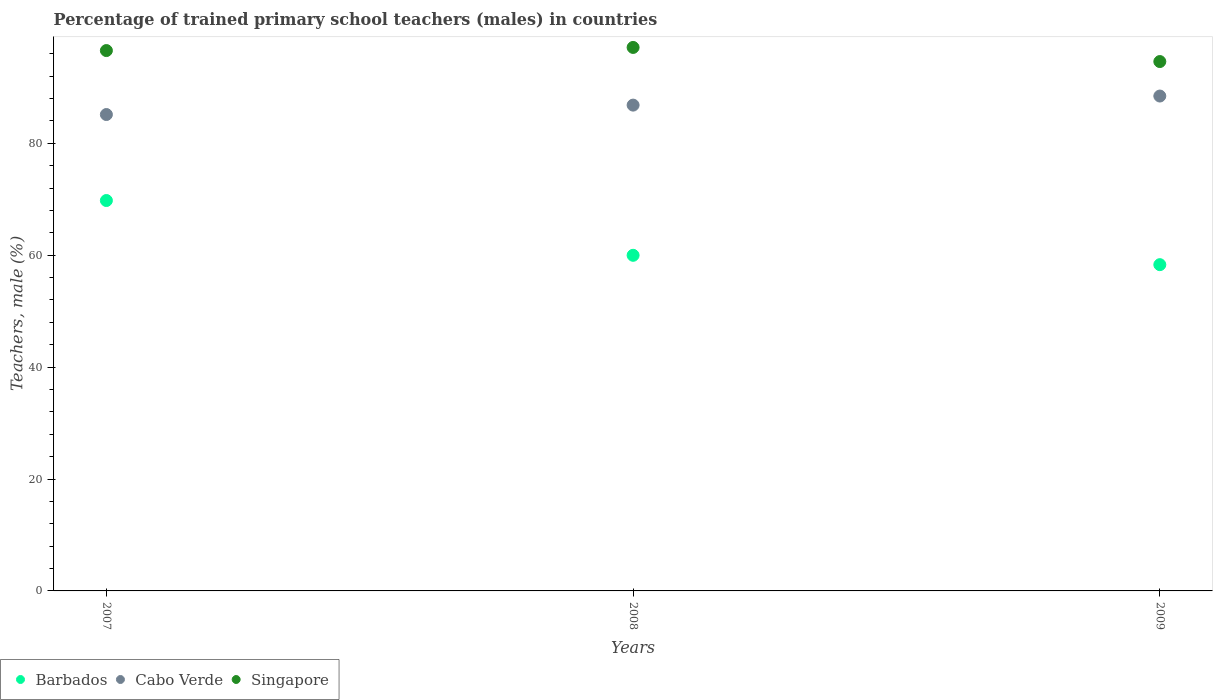What is the percentage of trained primary school teachers (males) in Singapore in 2008?
Your answer should be very brief. 97.14. Across all years, what is the maximum percentage of trained primary school teachers (males) in Cabo Verde?
Offer a very short reply. 88.45. Across all years, what is the minimum percentage of trained primary school teachers (males) in Barbados?
Your response must be concise. 58.31. In which year was the percentage of trained primary school teachers (males) in Singapore maximum?
Offer a very short reply. 2008. What is the total percentage of trained primary school teachers (males) in Cabo Verde in the graph?
Offer a terse response. 260.43. What is the difference between the percentage of trained primary school teachers (males) in Cabo Verde in 2007 and that in 2008?
Your answer should be compact. -1.68. What is the difference between the percentage of trained primary school teachers (males) in Cabo Verde in 2008 and the percentage of trained primary school teachers (males) in Barbados in 2007?
Your answer should be very brief. 17.05. What is the average percentage of trained primary school teachers (males) in Cabo Verde per year?
Your answer should be very brief. 86.81. In the year 2008, what is the difference between the percentage of trained primary school teachers (males) in Cabo Verde and percentage of trained primary school teachers (males) in Singapore?
Your answer should be very brief. -10.31. What is the ratio of the percentage of trained primary school teachers (males) in Singapore in 2008 to that in 2009?
Provide a short and direct response. 1.03. Is the difference between the percentage of trained primary school teachers (males) in Cabo Verde in 2007 and 2009 greater than the difference between the percentage of trained primary school teachers (males) in Singapore in 2007 and 2009?
Your response must be concise. No. What is the difference between the highest and the second highest percentage of trained primary school teachers (males) in Barbados?
Offer a terse response. 9.79. What is the difference between the highest and the lowest percentage of trained primary school teachers (males) in Cabo Verde?
Your answer should be compact. 3.31. In how many years, is the percentage of trained primary school teachers (males) in Cabo Verde greater than the average percentage of trained primary school teachers (males) in Cabo Verde taken over all years?
Your response must be concise. 2. Is it the case that in every year, the sum of the percentage of trained primary school teachers (males) in Barbados and percentage of trained primary school teachers (males) in Singapore  is greater than the percentage of trained primary school teachers (males) in Cabo Verde?
Your answer should be very brief. Yes. Are the values on the major ticks of Y-axis written in scientific E-notation?
Give a very brief answer. No. Does the graph contain grids?
Make the answer very short. No. Where does the legend appear in the graph?
Your answer should be very brief. Bottom left. How are the legend labels stacked?
Offer a very short reply. Horizontal. What is the title of the graph?
Provide a short and direct response. Percentage of trained primary school teachers (males) in countries. Does "Benin" appear as one of the legend labels in the graph?
Offer a very short reply. No. What is the label or title of the X-axis?
Make the answer very short. Years. What is the label or title of the Y-axis?
Give a very brief answer. Teachers, male (%). What is the Teachers, male (%) of Barbados in 2007?
Keep it short and to the point. 69.78. What is the Teachers, male (%) in Cabo Verde in 2007?
Your response must be concise. 85.15. What is the Teachers, male (%) of Singapore in 2007?
Your answer should be compact. 96.58. What is the Teachers, male (%) in Barbados in 2008?
Offer a very short reply. 59.99. What is the Teachers, male (%) of Cabo Verde in 2008?
Ensure brevity in your answer.  86.83. What is the Teachers, male (%) in Singapore in 2008?
Make the answer very short. 97.14. What is the Teachers, male (%) in Barbados in 2009?
Ensure brevity in your answer.  58.31. What is the Teachers, male (%) of Cabo Verde in 2009?
Your answer should be compact. 88.45. What is the Teachers, male (%) in Singapore in 2009?
Ensure brevity in your answer.  94.61. Across all years, what is the maximum Teachers, male (%) in Barbados?
Your answer should be very brief. 69.78. Across all years, what is the maximum Teachers, male (%) in Cabo Verde?
Offer a terse response. 88.45. Across all years, what is the maximum Teachers, male (%) of Singapore?
Your answer should be compact. 97.14. Across all years, what is the minimum Teachers, male (%) in Barbados?
Keep it short and to the point. 58.31. Across all years, what is the minimum Teachers, male (%) of Cabo Verde?
Offer a terse response. 85.15. Across all years, what is the minimum Teachers, male (%) in Singapore?
Your answer should be very brief. 94.61. What is the total Teachers, male (%) of Barbados in the graph?
Provide a short and direct response. 188.08. What is the total Teachers, male (%) in Cabo Verde in the graph?
Your response must be concise. 260.43. What is the total Teachers, male (%) in Singapore in the graph?
Provide a succinct answer. 288.33. What is the difference between the Teachers, male (%) of Barbados in 2007 and that in 2008?
Give a very brief answer. 9.79. What is the difference between the Teachers, male (%) of Cabo Verde in 2007 and that in 2008?
Your response must be concise. -1.68. What is the difference between the Teachers, male (%) of Singapore in 2007 and that in 2008?
Offer a very short reply. -0.56. What is the difference between the Teachers, male (%) of Barbados in 2007 and that in 2009?
Provide a short and direct response. 11.46. What is the difference between the Teachers, male (%) in Cabo Verde in 2007 and that in 2009?
Keep it short and to the point. -3.31. What is the difference between the Teachers, male (%) in Singapore in 2007 and that in 2009?
Make the answer very short. 1.96. What is the difference between the Teachers, male (%) in Barbados in 2008 and that in 2009?
Your answer should be compact. 1.67. What is the difference between the Teachers, male (%) of Cabo Verde in 2008 and that in 2009?
Your response must be concise. -1.62. What is the difference between the Teachers, male (%) of Singapore in 2008 and that in 2009?
Your answer should be compact. 2.52. What is the difference between the Teachers, male (%) of Barbados in 2007 and the Teachers, male (%) of Cabo Verde in 2008?
Your response must be concise. -17.05. What is the difference between the Teachers, male (%) in Barbados in 2007 and the Teachers, male (%) in Singapore in 2008?
Offer a very short reply. -27.36. What is the difference between the Teachers, male (%) in Cabo Verde in 2007 and the Teachers, male (%) in Singapore in 2008?
Your answer should be very brief. -11.99. What is the difference between the Teachers, male (%) of Barbados in 2007 and the Teachers, male (%) of Cabo Verde in 2009?
Ensure brevity in your answer.  -18.68. What is the difference between the Teachers, male (%) of Barbados in 2007 and the Teachers, male (%) of Singapore in 2009?
Your answer should be compact. -24.84. What is the difference between the Teachers, male (%) of Cabo Verde in 2007 and the Teachers, male (%) of Singapore in 2009?
Make the answer very short. -9.47. What is the difference between the Teachers, male (%) in Barbados in 2008 and the Teachers, male (%) in Cabo Verde in 2009?
Your answer should be compact. -28.47. What is the difference between the Teachers, male (%) of Barbados in 2008 and the Teachers, male (%) of Singapore in 2009?
Make the answer very short. -34.63. What is the difference between the Teachers, male (%) in Cabo Verde in 2008 and the Teachers, male (%) in Singapore in 2009?
Give a very brief answer. -7.79. What is the average Teachers, male (%) of Barbados per year?
Provide a succinct answer. 62.69. What is the average Teachers, male (%) in Cabo Verde per year?
Offer a very short reply. 86.81. What is the average Teachers, male (%) in Singapore per year?
Offer a very short reply. 96.11. In the year 2007, what is the difference between the Teachers, male (%) of Barbados and Teachers, male (%) of Cabo Verde?
Provide a succinct answer. -15.37. In the year 2007, what is the difference between the Teachers, male (%) of Barbados and Teachers, male (%) of Singapore?
Provide a short and direct response. -26.8. In the year 2007, what is the difference between the Teachers, male (%) in Cabo Verde and Teachers, male (%) in Singapore?
Provide a short and direct response. -11.43. In the year 2008, what is the difference between the Teachers, male (%) of Barbados and Teachers, male (%) of Cabo Verde?
Your answer should be compact. -26.84. In the year 2008, what is the difference between the Teachers, male (%) of Barbados and Teachers, male (%) of Singapore?
Your answer should be compact. -37.15. In the year 2008, what is the difference between the Teachers, male (%) in Cabo Verde and Teachers, male (%) in Singapore?
Provide a succinct answer. -10.31. In the year 2009, what is the difference between the Teachers, male (%) of Barbados and Teachers, male (%) of Cabo Verde?
Offer a very short reply. -30.14. In the year 2009, what is the difference between the Teachers, male (%) in Barbados and Teachers, male (%) in Singapore?
Your answer should be compact. -36.3. In the year 2009, what is the difference between the Teachers, male (%) of Cabo Verde and Teachers, male (%) of Singapore?
Ensure brevity in your answer.  -6.16. What is the ratio of the Teachers, male (%) of Barbados in 2007 to that in 2008?
Make the answer very short. 1.16. What is the ratio of the Teachers, male (%) of Cabo Verde in 2007 to that in 2008?
Make the answer very short. 0.98. What is the ratio of the Teachers, male (%) of Barbados in 2007 to that in 2009?
Keep it short and to the point. 1.2. What is the ratio of the Teachers, male (%) in Cabo Verde in 2007 to that in 2009?
Make the answer very short. 0.96. What is the ratio of the Teachers, male (%) of Singapore in 2007 to that in 2009?
Your answer should be compact. 1.02. What is the ratio of the Teachers, male (%) of Barbados in 2008 to that in 2009?
Your answer should be very brief. 1.03. What is the ratio of the Teachers, male (%) in Cabo Verde in 2008 to that in 2009?
Provide a short and direct response. 0.98. What is the ratio of the Teachers, male (%) of Singapore in 2008 to that in 2009?
Your answer should be very brief. 1.03. What is the difference between the highest and the second highest Teachers, male (%) of Barbados?
Keep it short and to the point. 9.79. What is the difference between the highest and the second highest Teachers, male (%) in Cabo Verde?
Ensure brevity in your answer.  1.62. What is the difference between the highest and the second highest Teachers, male (%) of Singapore?
Offer a terse response. 0.56. What is the difference between the highest and the lowest Teachers, male (%) of Barbados?
Your answer should be compact. 11.46. What is the difference between the highest and the lowest Teachers, male (%) in Cabo Verde?
Your response must be concise. 3.31. What is the difference between the highest and the lowest Teachers, male (%) of Singapore?
Your answer should be very brief. 2.52. 